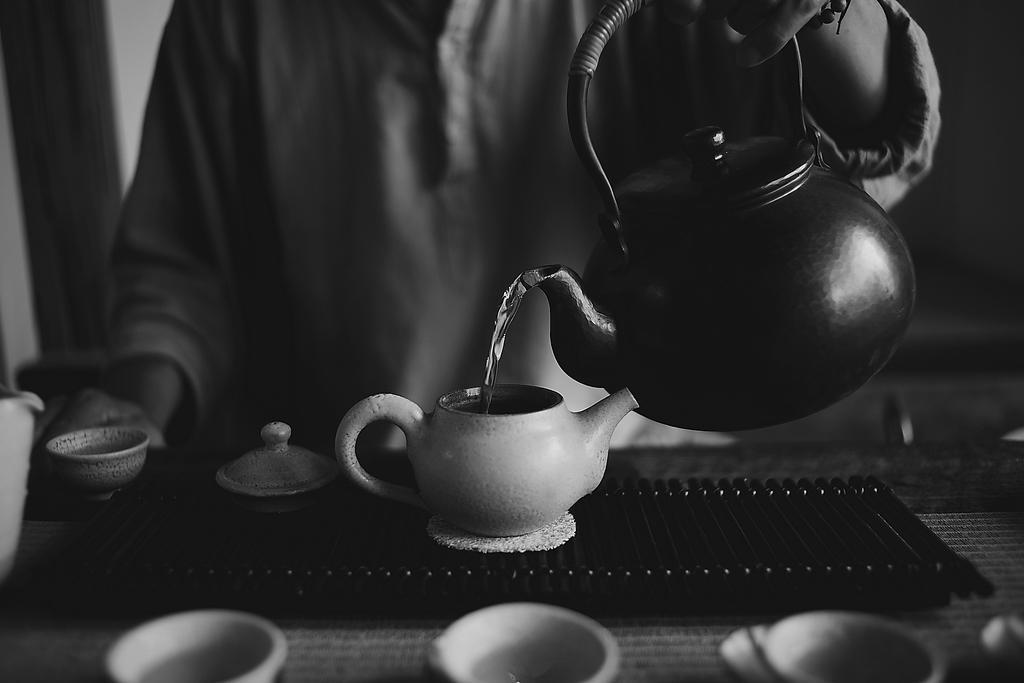How would you summarize this image in a sentence or two? This is a black and white image. I can see a person holding a kettle and pouring water into another kettle. This is the table with cups, kettle, lid and few other objects on it. 